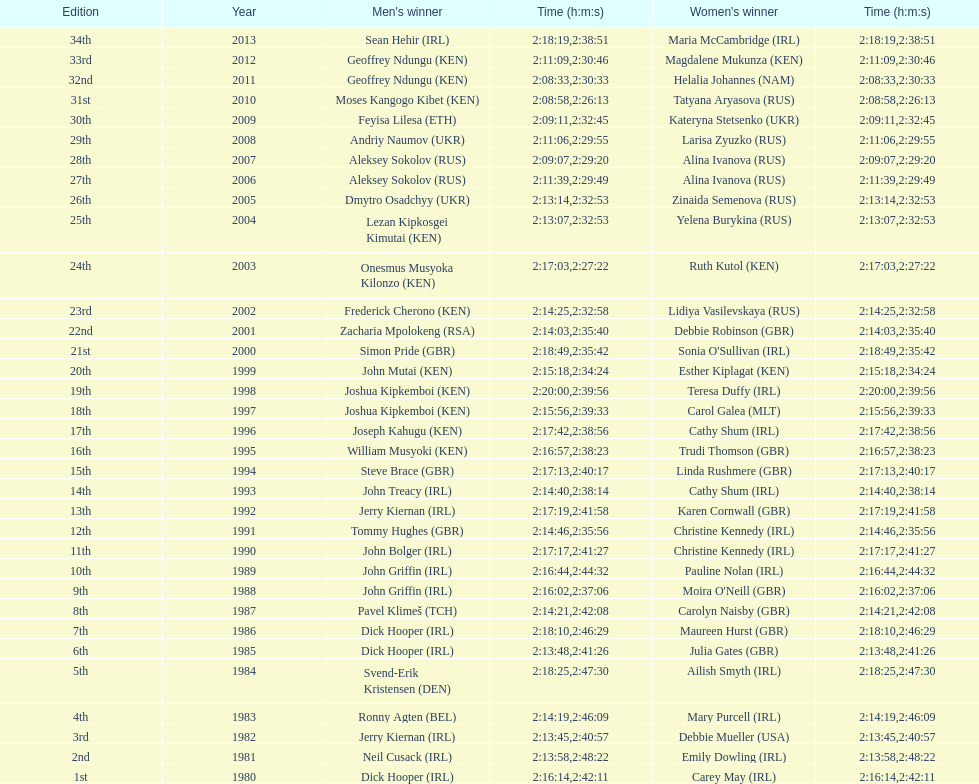Who was the victor following the conclusion of joseph kipkemboi's series of wins? John Mutai (KEN). 